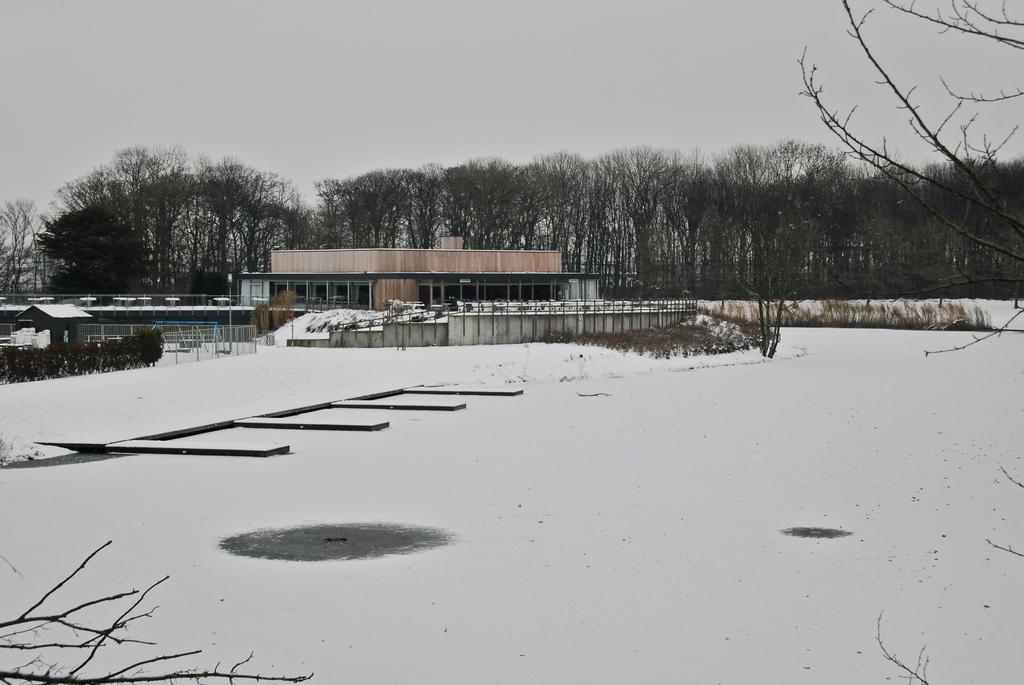Can you describe this image briefly? This picture is clicked outside the city. In the foreground we can the snow. In the center we can see the buildings, metal rods. In the background there is a sky and the trees.. 